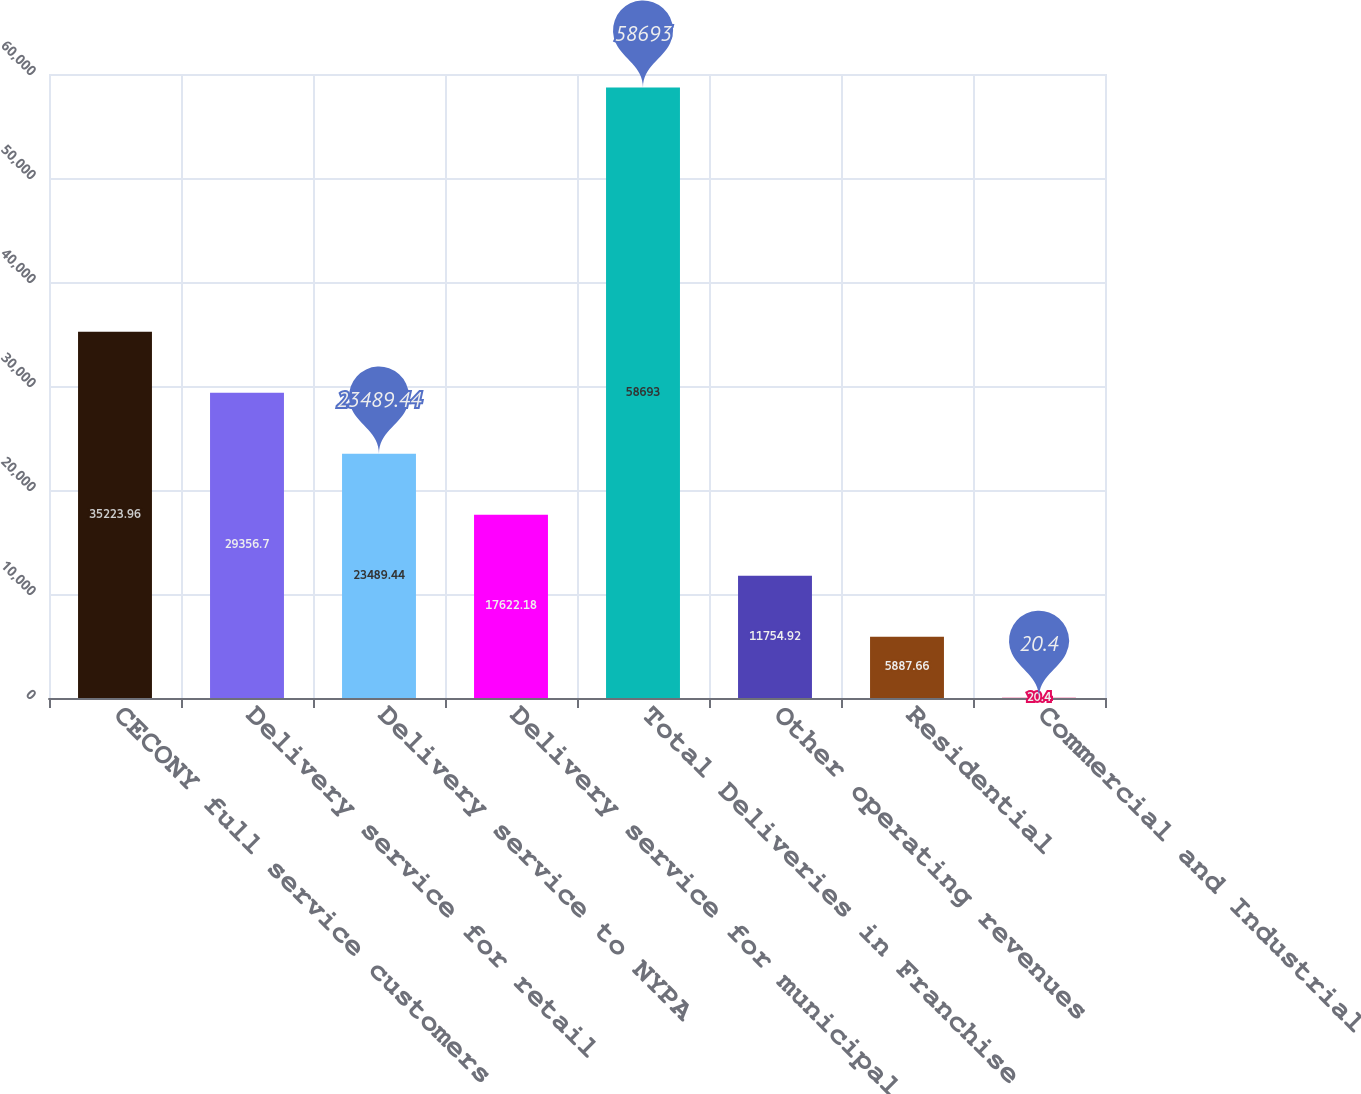Convert chart. <chart><loc_0><loc_0><loc_500><loc_500><bar_chart><fcel>CECONY full service customers<fcel>Delivery service for retail<fcel>Delivery service to NYPA<fcel>Delivery service for municipal<fcel>Total Deliveries in Franchise<fcel>Other operating revenues<fcel>Residential<fcel>Commercial and Industrial<nl><fcel>35224<fcel>29356.7<fcel>23489.4<fcel>17622.2<fcel>58693<fcel>11754.9<fcel>5887.66<fcel>20.4<nl></chart> 